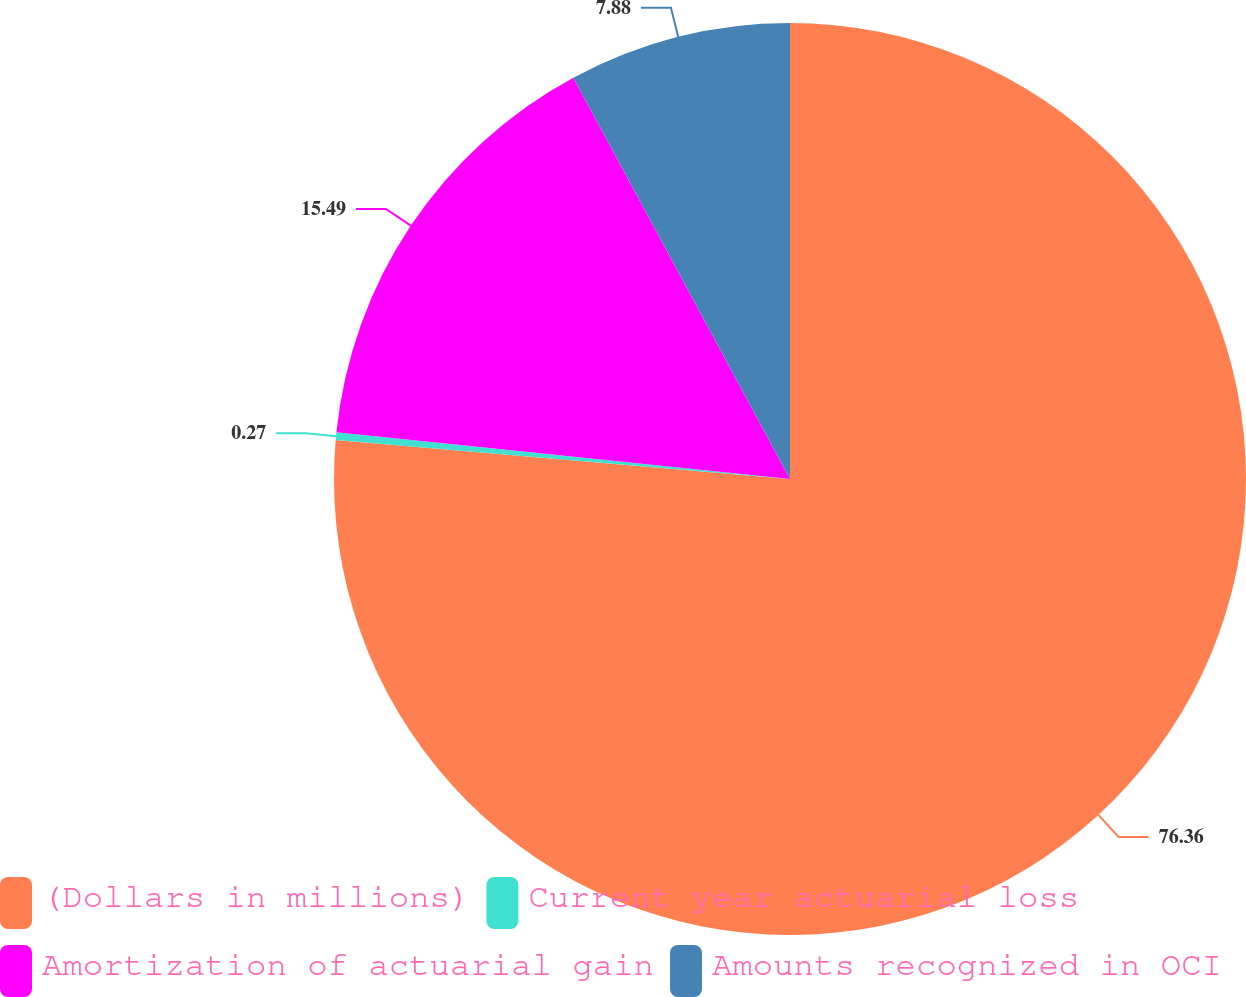Convert chart to OTSL. <chart><loc_0><loc_0><loc_500><loc_500><pie_chart><fcel>(Dollars in millions)<fcel>Current year actuarial loss<fcel>Amortization of actuarial gain<fcel>Amounts recognized in OCI<nl><fcel>76.37%<fcel>0.27%<fcel>15.49%<fcel>7.88%<nl></chart> 